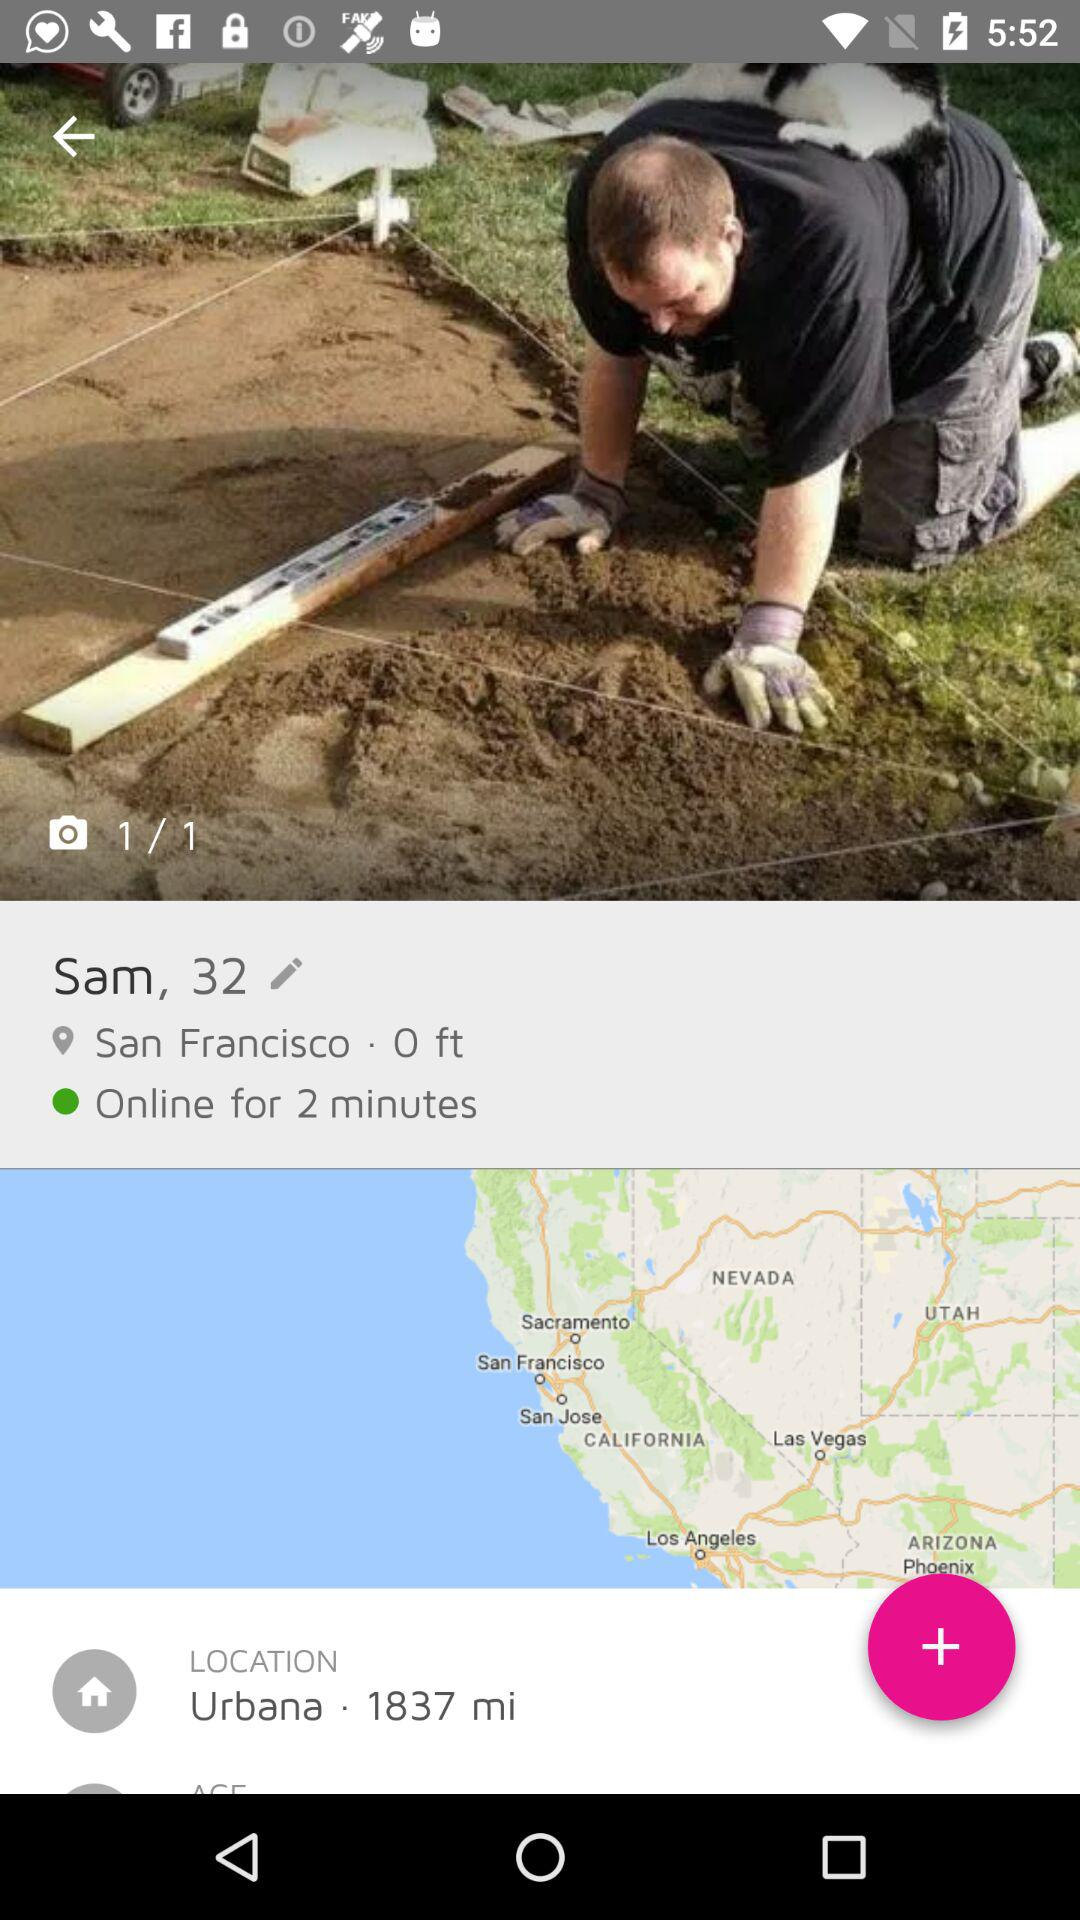What is the age of Sam? Sam is 32 years old. 